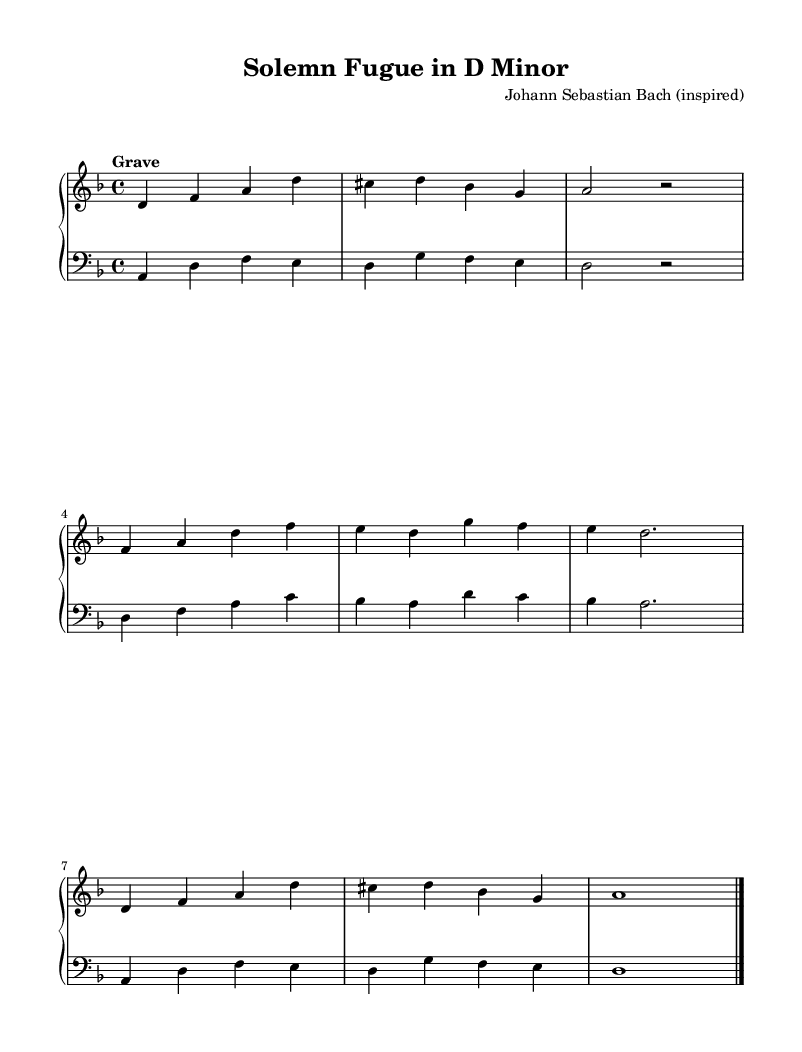What is the key signature of this music? The key signature is D minor, which has one flat (B flat). The key is indicated at the beginning of the staff.
Answer: D minor What is the time signature of this piece? The time signature is 4/4, indicated at the start of the music. This means there are four beats in a measure and the quarter note gets one beat.
Answer: 4/4 What is the tempo marking for this composition? The tempo marking in the score is "Grave", which indicates a very slow and solemn pace. It is typically associated with a dignified and serious mood.
Answer: Grave How many measures are present in the exposition section? The exposition section contains 3 measures, which is the initial section of a fugue and introduces the main themes.
Answer: 3 What is the last note of the recapitulation section in the right hand? The last note in the right hand of the recapitulation section is A, which is shown in the final measure of the section.
Answer: A How do the left and right hand notes relate in the exposition? In the exposition, both hands often play in harmony, with the left hand supporting the melody in the right hand, creating a rich, intertwined texture typical of Baroque style. This is seen as they both play complementary rhythms and harmonies.
Answer: Complementary What could be the emotional effect of playing this piece on a church organ? The emotional effect can be one of reverence or solemnity, as organ works from the Baroque era often aim to evoke a sense of discipline and contemplation, especially when played in a church setting.
Answer: Reverence 